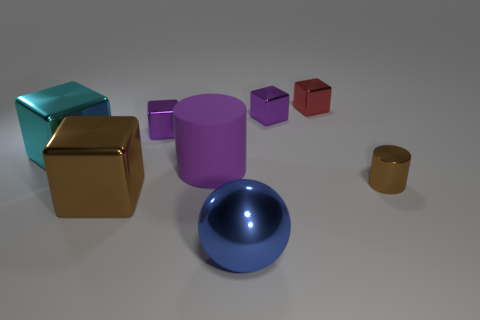How many spheres are tiny green metal objects or large purple matte objects?
Ensure brevity in your answer.  0. What is the material of the big cube that is the same color as the small cylinder?
Ensure brevity in your answer.  Metal. Does the purple metal thing on the left side of the large cylinder have the same shape as the object that is to the right of the red block?
Provide a short and direct response. No. What color is the metallic object that is right of the brown metal cube and left of the large purple cylinder?
Make the answer very short. Purple. Does the tiny metal cylinder have the same color as the large shiny block that is behind the tiny brown shiny object?
Offer a very short reply. No. How big is the metal cube that is both right of the large rubber cylinder and to the left of the red shiny cube?
Ensure brevity in your answer.  Small. What number of other things are there of the same color as the big rubber cylinder?
Your answer should be compact. 2. How big is the metal thing in front of the cube that is in front of the cylinder to the right of the red metal thing?
Ensure brevity in your answer.  Large. Are there any tiny brown metal things left of the big brown shiny cube?
Provide a short and direct response. No. There is a shiny cylinder; does it have the same size as the purple metallic thing that is on the left side of the metal sphere?
Provide a succinct answer. Yes. 